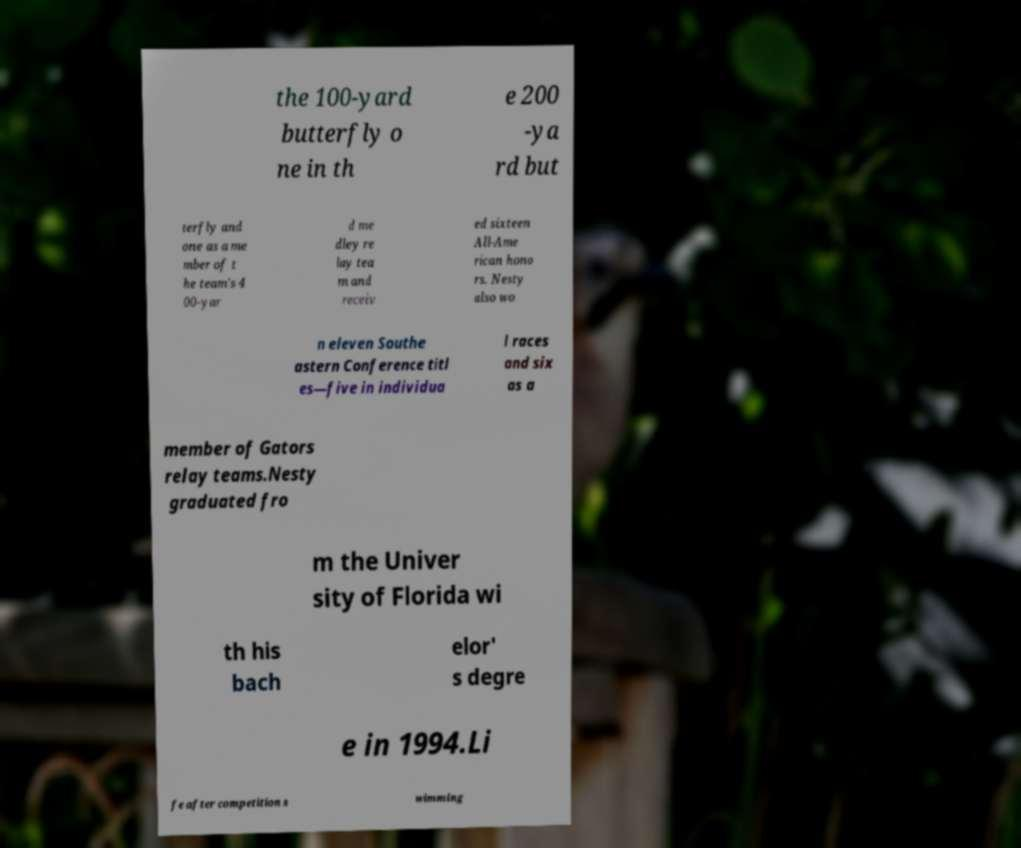Could you extract and type out the text from this image? the 100-yard butterfly o ne in th e 200 -ya rd but terfly and one as a me mber of t he team's 4 00-yar d me dley re lay tea m and receiv ed sixteen All-Ame rican hono rs. Nesty also wo n eleven Southe astern Conference titl es—five in individua l races and six as a member of Gators relay teams.Nesty graduated fro m the Univer sity of Florida wi th his bach elor' s degre e in 1994.Li fe after competition s wimming 